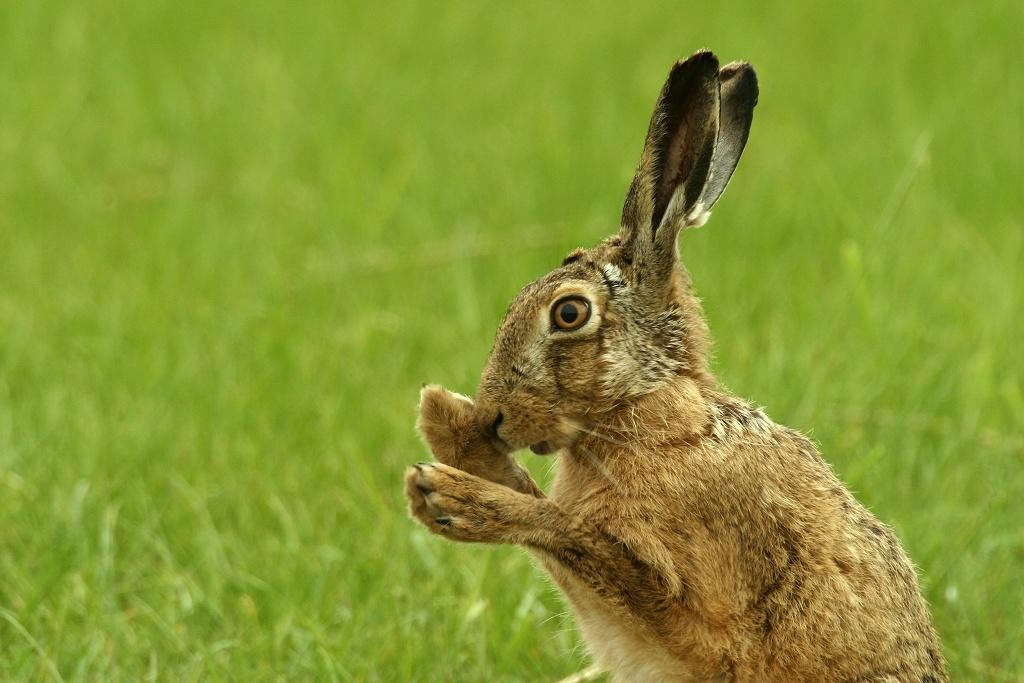What type of animal is in the image? The animal in the image is not specified, but it has brown, black, and cream colors. Can you describe the colors of the animal? The animal has brown, black, and cream colors. What is visible in the background of the image? There is green grass in the background of the image. What type of oven is visible in the image? There is no oven present in the image. How quiet is the animal in the image? The facts do not mention the animal's behavior or sounds, so we cannot determine how quiet the animal is. 